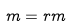<formula> <loc_0><loc_0><loc_500><loc_500>m = r m</formula> 